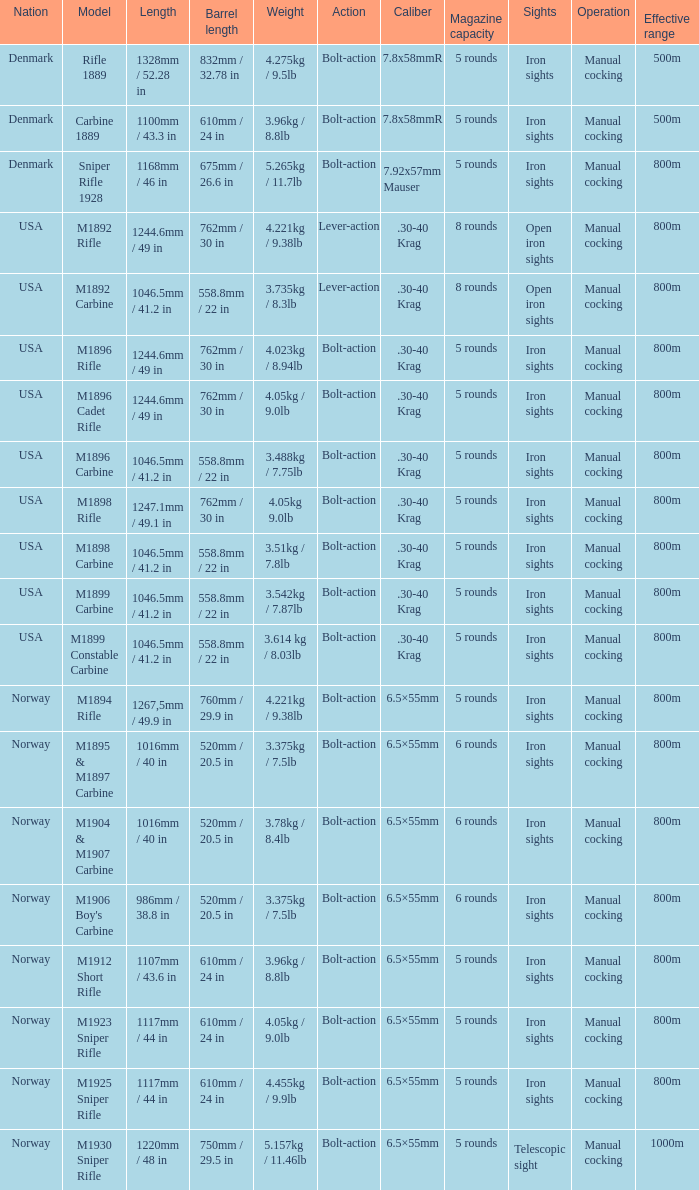What is Weight, when Length is 1168mm / 46 in? 5.265kg / 11.7lb. 